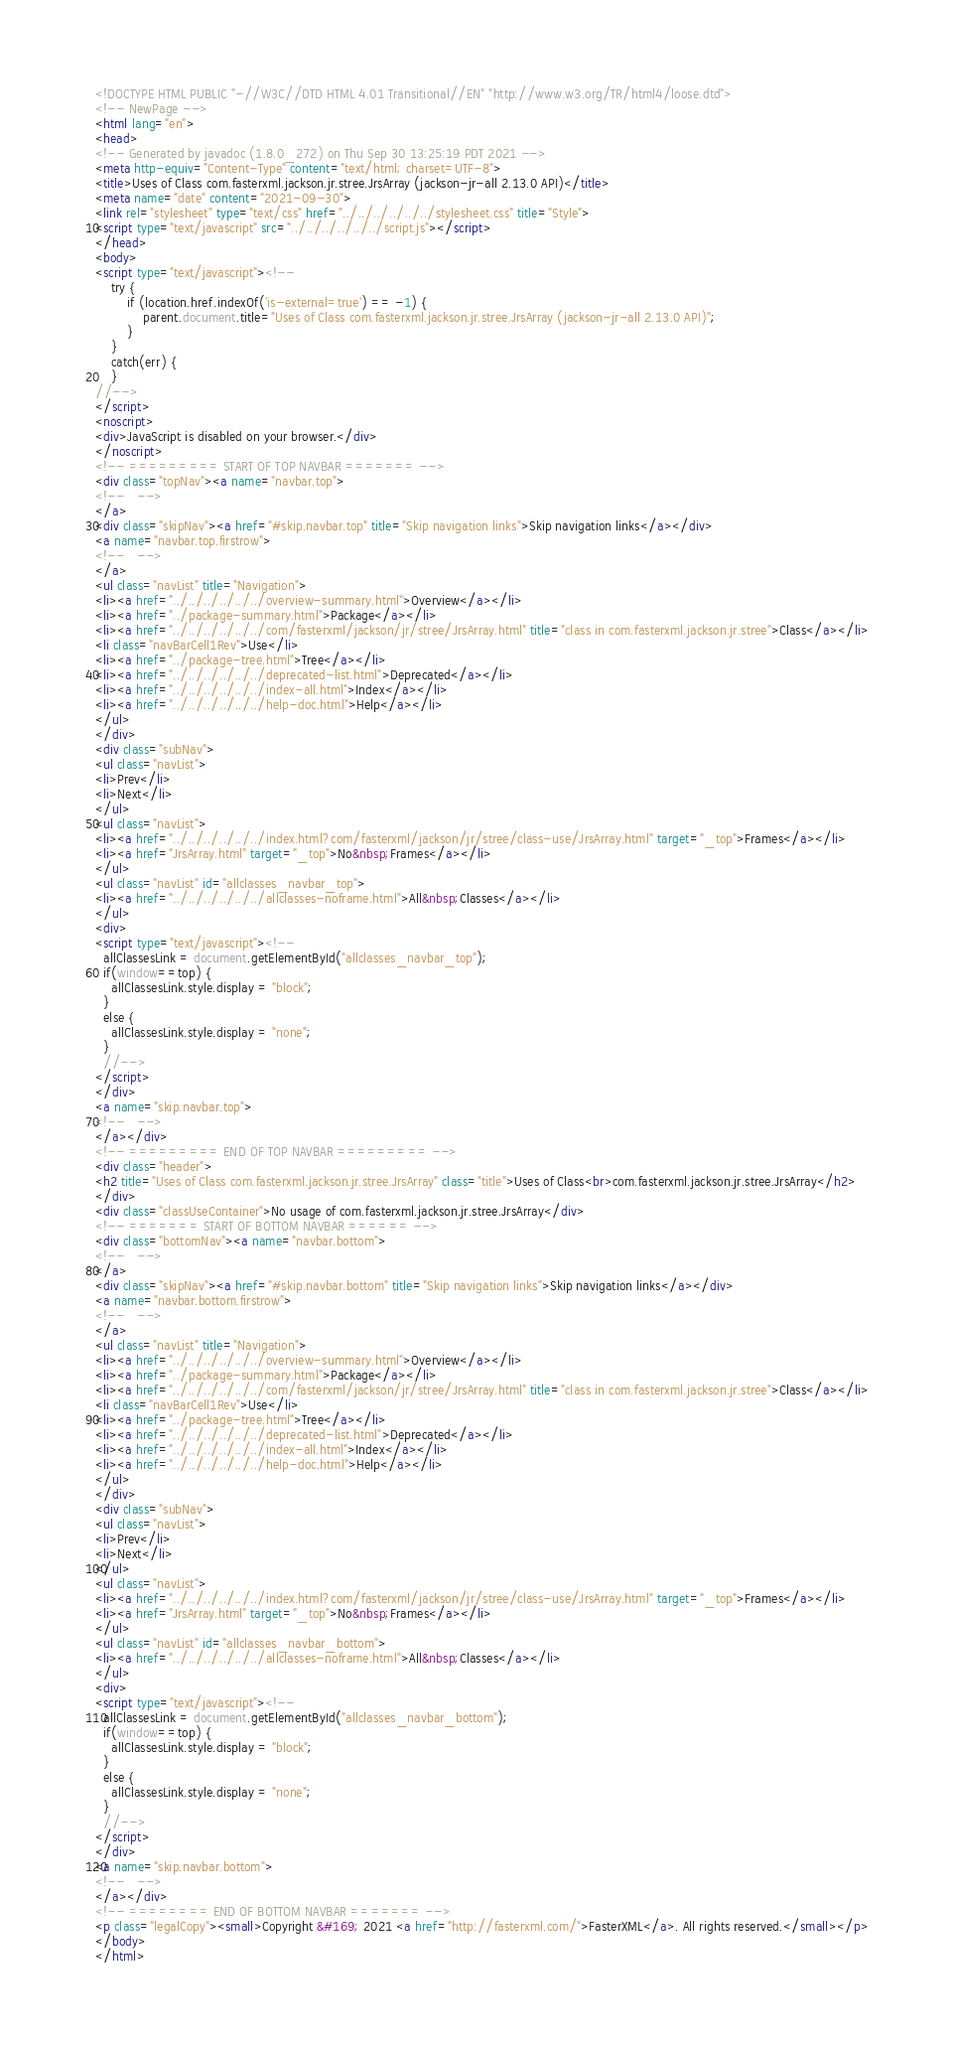Convert code to text. <code><loc_0><loc_0><loc_500><loc_500><_HTML_><!DOCTYPE HTML PUBLIC "-//W3C//DTD HTML 4.01 Transitional//EN" "http://www.w3.org/TR/html4/loose.dtd">
<!-- NewPage -->
<html lang="en">
<head>
<!-- Generated by javadoc (1.8.0_272) on Thu Sep 30 13:25:19 PDT 2021 -->
<meta http-equiv="Content-Type" content="text/html; charset=UTF-8">
<title>Uses of Class com.fasterxml.jackson.jr.stree.JrsArray (jackson-jr-all 2.13.0 API)</title>
<meta name="date" content="2021-09-30">
<link rel="stylesheet" type="text/css" href="../../../../../../stylesheet.css" title="Style">
<script type="text/javascript" src="../../../../../../script.js"></script>
</head>
<body>
<script type="text/javascript"><!--
    try {
        if (location.href.indexOf('is-external=true') == -1) {
            parent.document.title="Uses of Class com.fasterxml.jackson.jr.stree.JrsArray (jackson-jr-all 2.13.0 API)";
        }
    }
    catch(err) {
    }
//-->
</script>
<noscript>
<div>JavaScript is disabled on your browser.</div>
</noscript>
<!-- ========= START OF TOP NAVBAR ======= -->
<div class="topNav"><a name="navbar.top">
<!--   -->
</a>
<div class="skipNav"><a href="#skip.navbar.top" title="Skip navigation links">Skip navigation links</a></div>
<a name="navbar.top.firstrow">
<!--   -->
</a>
<ul class="navList" title="Navigation">
<li><a href="../../../../../../overview-summary.html">Overview</a></li>
<li><a href="../package-summary.html">Package</a></li>
<li><a href="../../../../../../com/fasterxml/jackson/jr/stree/JrsArray.html" title="class in com.fasterxml.jackson.jr.stree">Class</a></li>
<li class="navBarCell1Rev">Use</li>
<li><a href="../package-tree.html">Tree</a></li>
<li><a href="../../../../../../deprecated-list.html">Deprecated</a></li>
<li><a href="../../../../../../index-all.html">Index</a></li>
<li><a href="../../../../../../help-doc.html">Help</a></li>
</ul>
</div>
<div class="subNav">
<ul class="navList">
<li>Prev</li>
<li>Next</li>
</ul>
<ul class="navList">
<li><a href="../../../../../../index.html?com/fasterxml/jackson/jr/stree/class-use/JrsArray.html" target="_top">Frames</a></li>
<li><a href="JrsArray.html" target="_top">No&nbsp;Frames</a></li>
</ul>
<ul class="navList" id="allclasses_navbar_top">
<li><a href="../../../../../../allclasses-noframe.html">All&nbsp;Classes</a></li>
</ul>
<div>
<script type="text/javascript"><!--
  allClassesLink = document.getElementById("allclasses_navbar_top");
  if(window==top) {
    allClassesLink.style.display = "block";
  }
  else {
    allClassesLink.style.display = "none";
  }
  //-->
</script>
</div>
<a name="skip.navbar.top">
<!--   -->
</a></div>
<!-- ========= END OF TOP NAVBAR ========= -->
<div class="header">
<h2 title="Uses of Class com.fasterxml.jackson.jr.stree.JrsArray" class="title">Uses of Class<br>com.fasterxml.jackson.jr.stree.JrsArray</h2>
</div>
<div class="classUseContainer">No usage of com.fasterxml.jackson.jr.stree.JrsArray</div>
<!-- ======= START OF BOTTOM NAVBAR ====== -->
<div class="bottomNav"><a name="navbar.bottom">
<!--   -->
</a>
<div class="skipNav"><a href="#skip.navbar.bottom" title="Skip navigation links">Skip navigation links</a></div>
<a name="navbar.bottom.firstrow">
<!--   -->
</a>
<ul class="navList" title="Navigation">
<li><a href="../../../../../../overview-summary.html">Overview</a></li>
<li><a href="../package-summary.html">Package</a></li>
<li><a href="../../../../../../com/fasterxml/jackson/jr/stree/JrsArray.html" title="class in com.fasterxml.jackson.jr.stree">Class</a></li>
<li class="navBarCell1Rev">Use</li>
<li><a href="../package-tree.html">Tree</a></li>
<li><a href="../../../../../../deprecated-list.html">Deprecated</a></li>
<li><a href="../../../../../../index-all.html">Index</a></li>
<li><a href="../../../../../../help-doc.html">Help</a></li>
</ul>
</div>
<div class="subNav">
<ul class="navList">
<li>Prev</li>
<li>Next</li>
</ul>
<ul class="navList">
<li><a href="../../../../../../index.html?com/fasterxml/jackson/jr/stree/class-use/JrsArray.html" target="_top">Frames</a></li>
<li><a href="JrsArray.html" target="_top">No&nbsp;Frames</a></li>
</ul>
<ul class="navList" id="allclasses_navbar_bottom">
<li><a href="../../../../../../allclasses-noframe.html">All&nbsp;Classes</a></li>
</ul>
<div>
<script type="text/javascript"><!--
  allClassesLink = document.getElementById("allclasses_navbar_bottom");
  if(window==top) {
    allClassesLink.style.display = "block";
  }
  else {
    allClassesLink.style.display = "none";
  }
  //-->
</script>
</div>
<a name="skip.navbar.bottom">
<!--   -->
</a></div>
<!-- ======== END OF BOTTOM NAVBAR ======= -->
<p class="legalCopy"><small>Copyright &#169; 2021 <a href="http://fasterxml.com/">FasterXML</a>. All rights reserved.</small></p>
</body>
</html>
</code> 